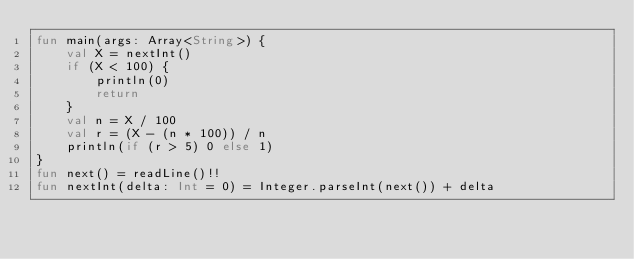Convert code to text. <code><loc_0><loc_0><loc_500><loc_500><_Kotlin_>fun main(args: Array<String>) {
    val X = nextInt()
    if (X < 100) {
        println(0)
        return
    }
    val n = X / 100
    val r = (X - (n * 100)) / n
    println(if (r > 5) 0 else 1)
}
fun next() = readLine()!!
fun nextInt(delta: Int = 0) = Integer.parseInt(next()) + delta</code> 